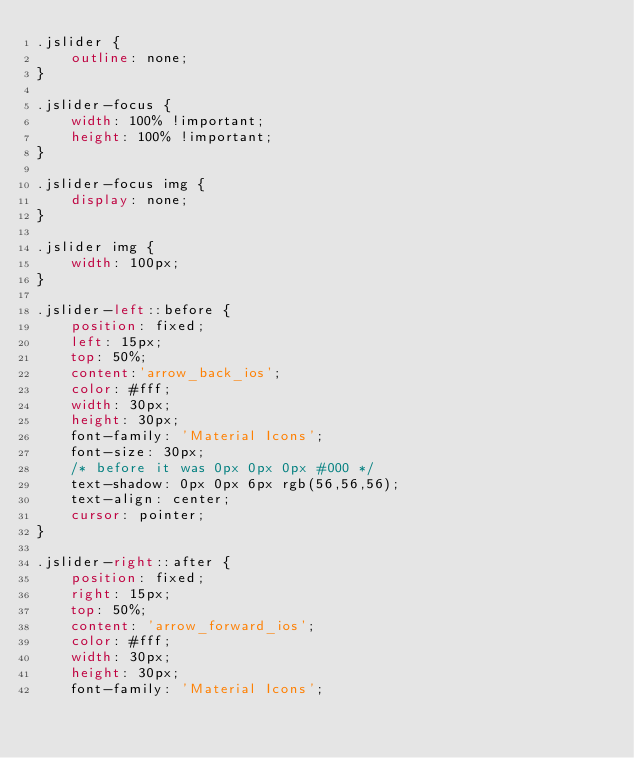<code> <loc_0><loc_0><loc_500><loc_500><_CSS_>.jslider {
    outline: none;
}

.jslider-focus {
    width: 100% !important;
    height: 100% !important;
}

.jslider-focus img {
    display: none;
}

.jslider img {
    width: 100px;
}

.jslider-left::before {
    position: fixed;
    left: 15px;
    top: 50%;
    content:'arrow_back_ios';
    color: #fff;
    width: 30px;
    height: 30px;
    font-family: 'Material Icons';
    font-size: 30px;
    /* before it was 0px 0px 0px #000 */
    text-shadow: 0px 0px 6px rgb(56,56,56);
    text-align: center;
    cursor: pointer;
}

.jslider-right::after {
    position: fixed;
    right: 15px;
    top: 50%;
    content: 'arrow_forward_ios';
    color: #fff;
    width: 30px;
    height: 30px;
    font-family: 'Material Icons';</code> 